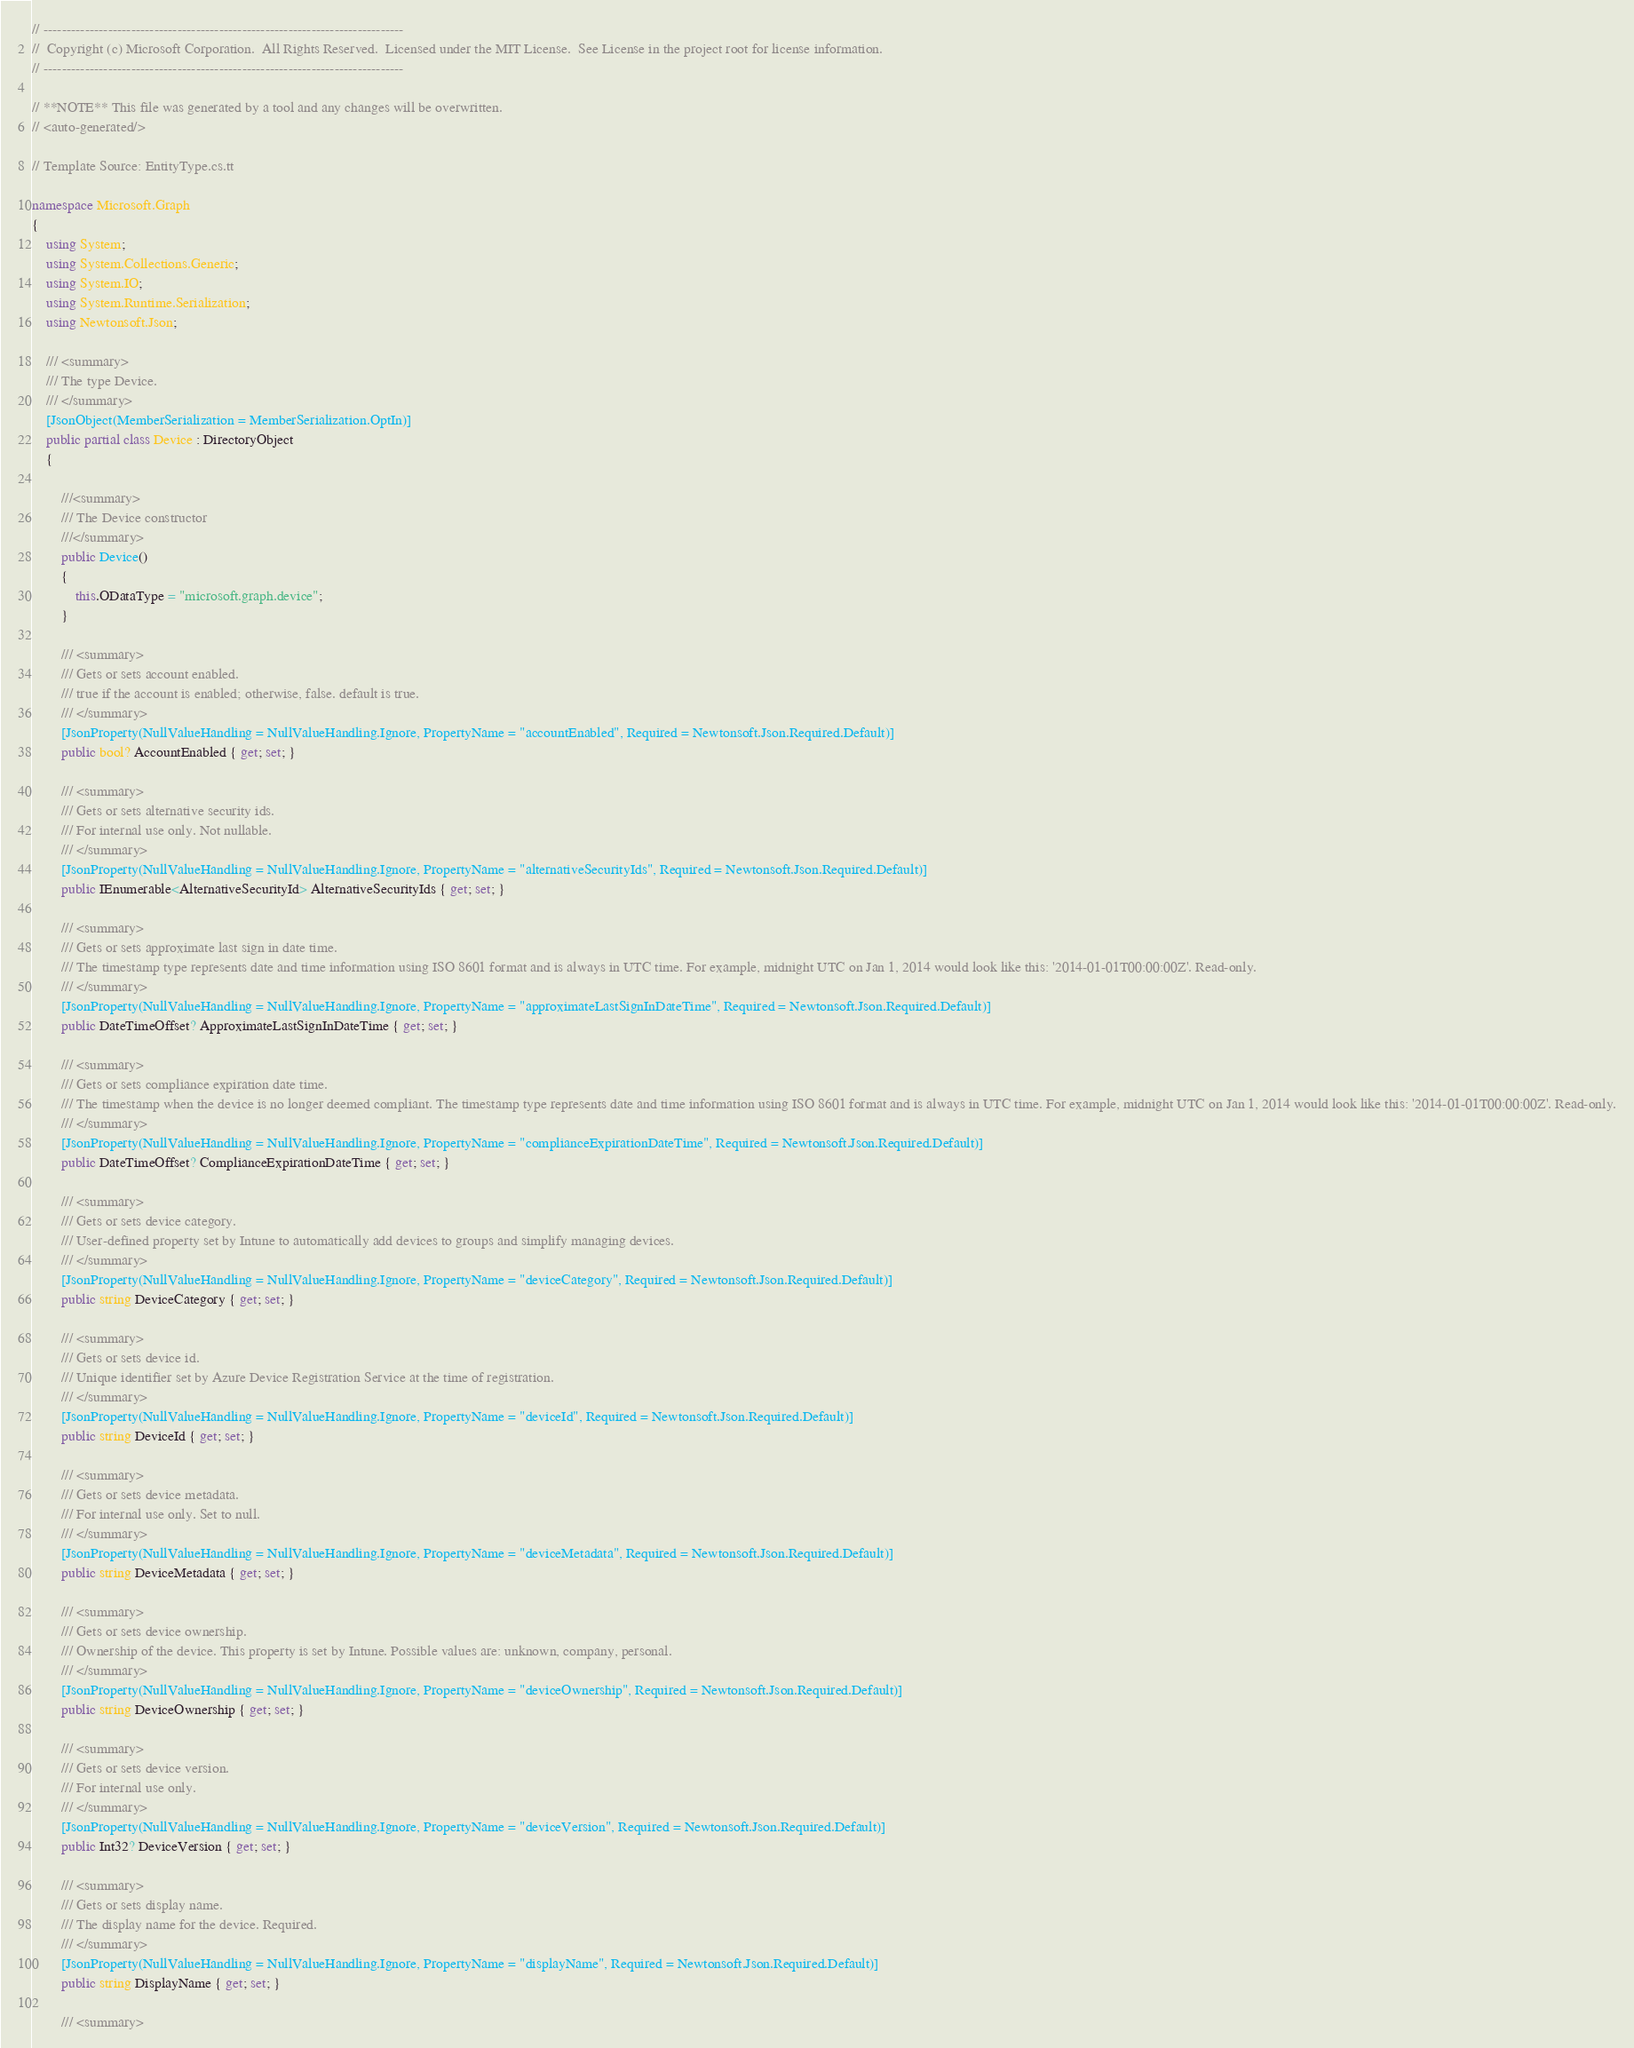<code> <loc_0><loc_0><loc_500><loc_500><_C#_>// ------------------------------------------------------------------------------
//  Copyright (c) Microsoft Corporation.  All Rights Reserved.  Licensed under the MIT License.  See License in the project root for license information.
// ------------------------------------------------------------------------------

// **NOTE** This file was generated by a tool and any changes will be overwritten.
// <auto-generated/>

// Template Source: EntityType.cs.tt

namespace Microsoft.Graph
{
    using System;
    using System.Collections.Generic;
    using System.IO;
    using System.Runtime.Serialization;
    using Newtonsoft.Json;

    /// <summary>
    /// The type Device.
    /// </summary>
    [JsonObject(MemberSerialization = MemberSerialization.OptIn)]
    public partial class Device : DirectoryObject
    {
    
		///<summary>
		/// The Device constructor
		///</summary>
        public Device()
        {
            this.ODataType = "microsoft.graph.device";
        }
	
        /// <summary>
        /// Gets or sets account enabled.
        /// true if the account is enabled; otherwise, false. default is true.
        /// </summary>
        [JsonProperty(NullValueHandling = NullValueHandling.Ignore, PropertyName = "accountEnabled", Required = Newtonsoft.Json.Required.Default)]
        public bool? AccountEnabled { get; set; }
    
        /// <summary>
        /// Gets or sets alternative security ids.
        /// For internal use only. Not nullable.
        /// </summary>
        [JsonProperty(NullValueHandling = NullValueHandling.Ignore, PropertyName = "alternativeSecurityIds", Required = Newtonsoft.Json.Required.Default)]
        public IEnumerable<AlternativeSecurityId> AlternativeSecurityIds { get; set; }
    
        /// <summary>
        /// Gets or sets approximate last sign in date time.
        /// The timestamp type represents date and time information using ISO 8601 format and is always in UTC time. For example, midnight UTC on Jan 1, 2014 would look like this: '2014-01-01T00:00:00Z'. Read-only.
        /// </summary>
        [JsonProperty(NullValueHandling = NullValueHandling.Ignore, PropertyName = "approximateLastSignInDateTime", Required = Newtonsoft.Json.Required.Default)]
        public DateTimeOffset? ApproximateLastSignInDateTime { get; set; }
    
        /// <summary>
        /// Gets or sets compliance expiration date time.
        /// The timestamp when the device is no longer deemed compliant. The timestamp type represents date and time information using ISO 8601 format and is always in UTC time. For example, midnight UTC on Jan 1, 2014 would look like this: '2014-01-01T00:00:00Z'. Read-only.
        /// </summary>
        [JsonProperty(NullValueHandling = NullValueHandling.Ignore, PropertyName = "complianceExpirationDateTime", Required = Newtonsoft.Json.Required.Default)]
        public DateTimeOffset? ComplianceExpirationDateTime { get; set; }
    
        /// <summary>
        /// Gets or sets device category.
        /// User-defined property set by Intune to automatically add devices to groups and simplify managing devices.
        /// </summary>
        [JsonProperty(NullValueHandling = NullValueHandling.Ignore, PropertyName = "deviceCategory", Required = Newtonsoft.Json.Required.Default)]
        public string DeviceCategory { get; set; }
    
        /// <summary>
        /// Gets or sets device id.
        /// Unique identifier set by Azure Device Registration Service at the time of registration.
        /// </summary>
        [JsonProperty(NullValueHandling = NullValueHandling.Ignore, PropertyName = "deviceId", Required = Newtonsoft.Json.Required.Default)]
        public string DeviceId { get; set; }
    
        /// <summary>
        /// Gets or sets device metadata.
        /// For internal use only. Set to null.
        /// </summary>
        [JsonProperty(NullValueHandling = NullValueHandling.Ignore, PropertyName = "deviceMetadata", Required = Newtonsoft.Json.Required.Default)]
        public string DeviceMetadata { get; set; }
    
        /// <summary>
        /// Gets or sets device ownership.
        /// Ownership of the device. This property is set by Intune. Possible values are: unknown, company, personal.
        /// </summary>
        [JsonProperty(NullValueHandling = NullValueHandling.Ignore, PropertyName = "deviceOwnership", Required = Newtonsoft.Json.Required.Default)]
        public string DeviceOwnership { get; set; }
    
        /// <summary>
        /// Gets or sets device version.
        /// For internal use only.
        /// </summary>
        [JsonProperty(NullValueHandling = NullValueHandling.Ignore, PropertyName = "deviceVersion", Required = Newtonsoft.Json.Required.Default)]
        public Int32? DeviceVersion { get; set; }
    
        /// <summary>
        /// Gets or sets display name.
        /// The display name for the device. Required.
        /// </summary>
        [JsonProperty(NullValueHandling = NullValueHandling.Ignore, PropertyName = "displayName", Required = Newtonsoft.Json.Required.Default)]
        public string DisplayName { get; set; }
    
        /// <summary></code> 